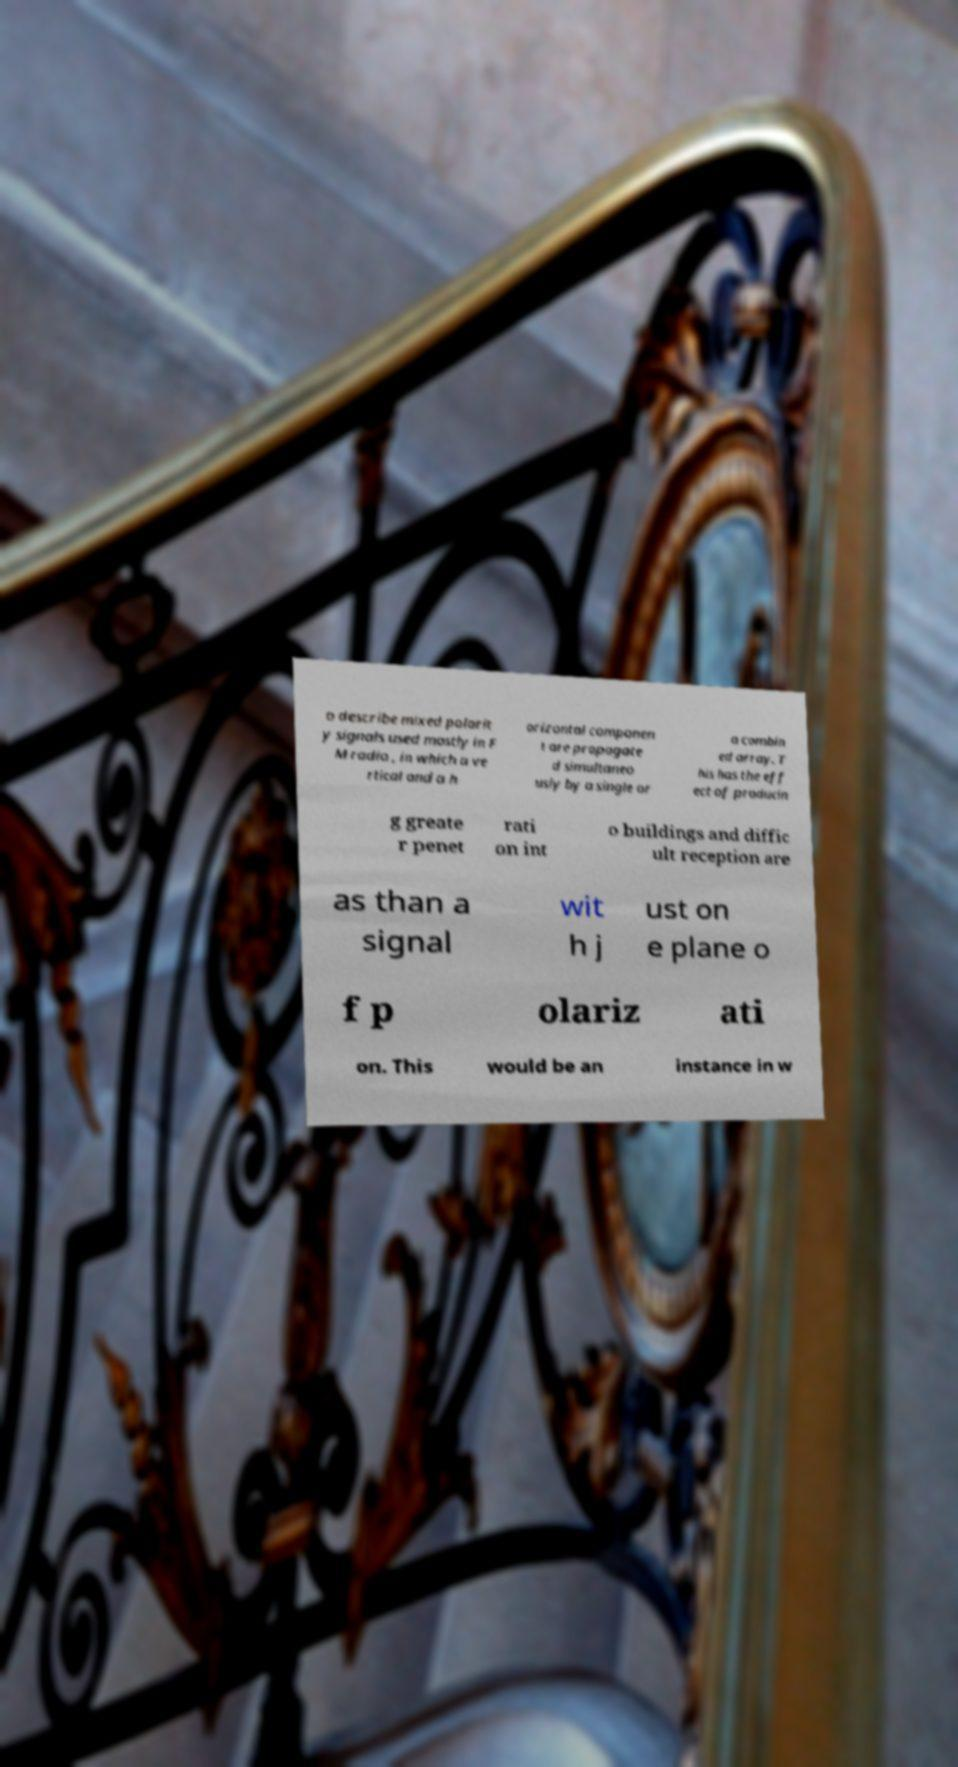I need the written content from this picture converted into text. Can you do that? o describe mixed polarit y signals used mostly in F M radio , in which a ve rtical and a h orizontal componen t are propagate d simultaneo usly by a single or a combin ed array. T his has the eff ect of producin g greate r penet rati on int o buildings and diffic ult reception are as than a signal wit h j ust on e plane o f p olariz ati on. This would be an instance in w 